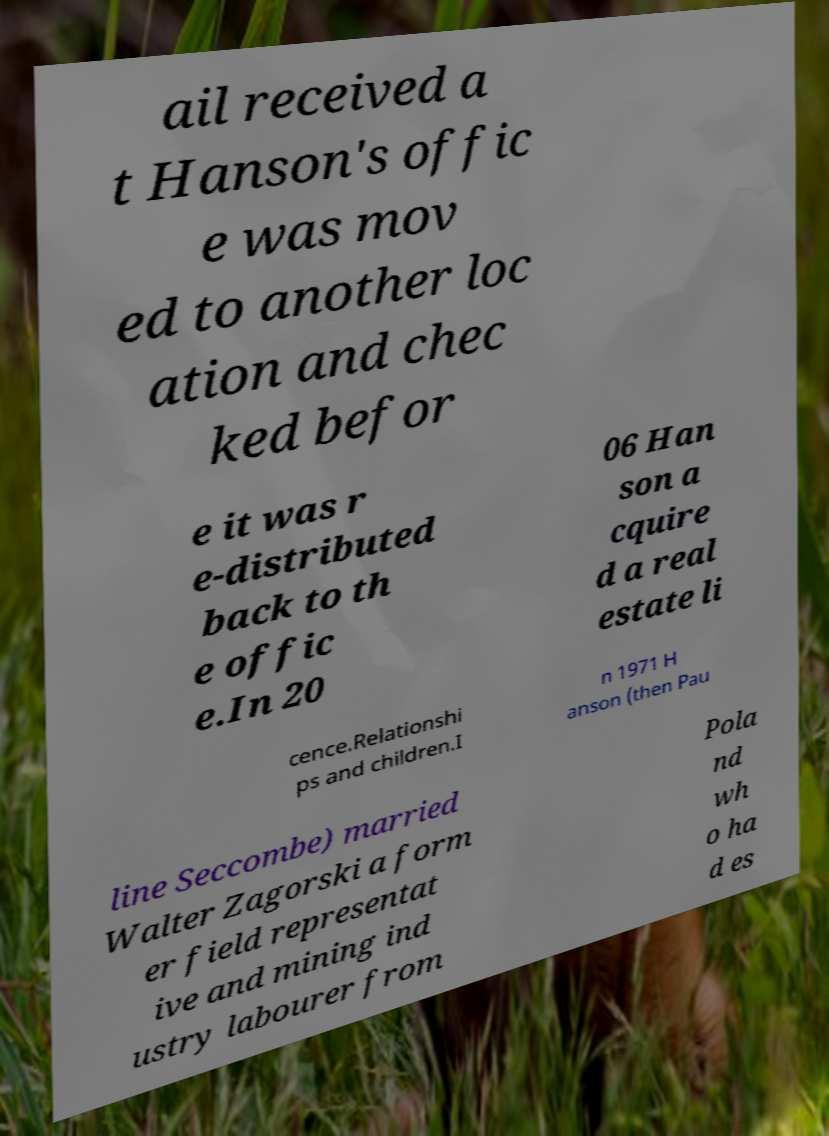What messages or text are displayed in this image? I need them in a readable, typed format. ail received a t Hanson's offic e was mov ed to another loc ation and chec ked befor e it was r e-distributed back to th e offic e.In 20 06 Han son a cquire d a real estate li cence.Relationshi ps and children.I n 1971 H anson (then Pau line Seccombe) married Walter Zagorski a form er field representat ive and mining ind ustry labourer from Pola nd wh o ha d es 